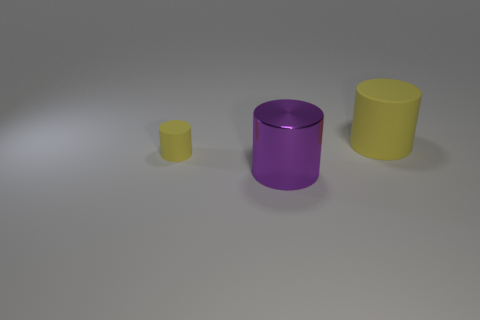Is the shape of the large yellow thing the same as the metal thing?
Provide a short and direct response. Yes. Are there an equal number of cylinders that are in front of the purple metal cylinder and tiny yellow cylinders that are behind the small yellow thing?
Your answer should be compact. Yes. What number of other things are made of the same material as the small yellow cylinder?
Keep it short and to the point. 1. How many small objects are purple metallic cylinders or yellow cubes?
Your answer should be very brief. 0. Are there the same number of big purple cylinders behind the tiny yellow rubber cylinder and tiny yellow matte things?
Provide a short and direct response. No. Are there any rubber cylinders that are right of the yellow cylinder left of the metal object?
Ensure brevity in your answer.  Yes. What number of other objects are there of the same color as the large matte cylinder?
Give a very brief answer. 1. The tiny cylinder has what color?
Offer a very short reply. Yellow. There is a cylinder that is on the left side of the big yellow matte cylinder and behind the large purple object; what size is it?
Offer a very short reply. Small. How many things are yellow cylinders that are left of the large purple metal thing or cyan metal spheres?
Ensure brevity in your answer.  1. 